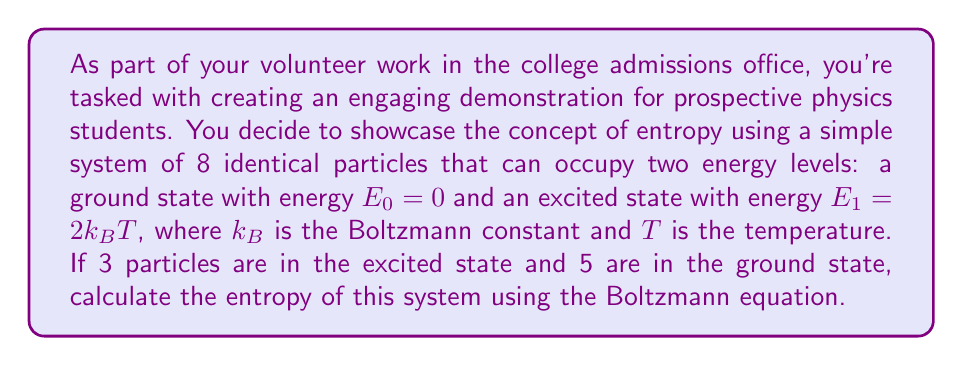Solve this math problem. Let's approach this step-by-step using the Boltzmann equation for entropy:

1) The Boltzmann equation for entropy is:
   $$S = k_B \ln W$$
   where $S$ is the entropy, $k_B$ is the Boltzmann constant, and $W$ is the number of microstates.

2) In this case, $W$ is the number of ways to arrange 3 particles in the excited state and 5 in the ground state out of 8 total particles. This is given by the combination formula:
   $$W = \binom{8}{3} = \frac{8!}{3!(8-3)!} = \frac{8!}{3!5!}$$

3) Calculate $W$:
   $$W = \frac{8 \cdot 7 \cdot 6 \cdot 5!}{(3 \cdot 2 \cdot 1) \cdot 5!} = 56$$

4) Now we can substitute this into the Boltzmann equation:
   $$S = k_B \ln 56$$

5) We can't simplify further without knowing the value of $k_B$, so this is our final answer.
Answer: $S = k_B \ln 56$ 